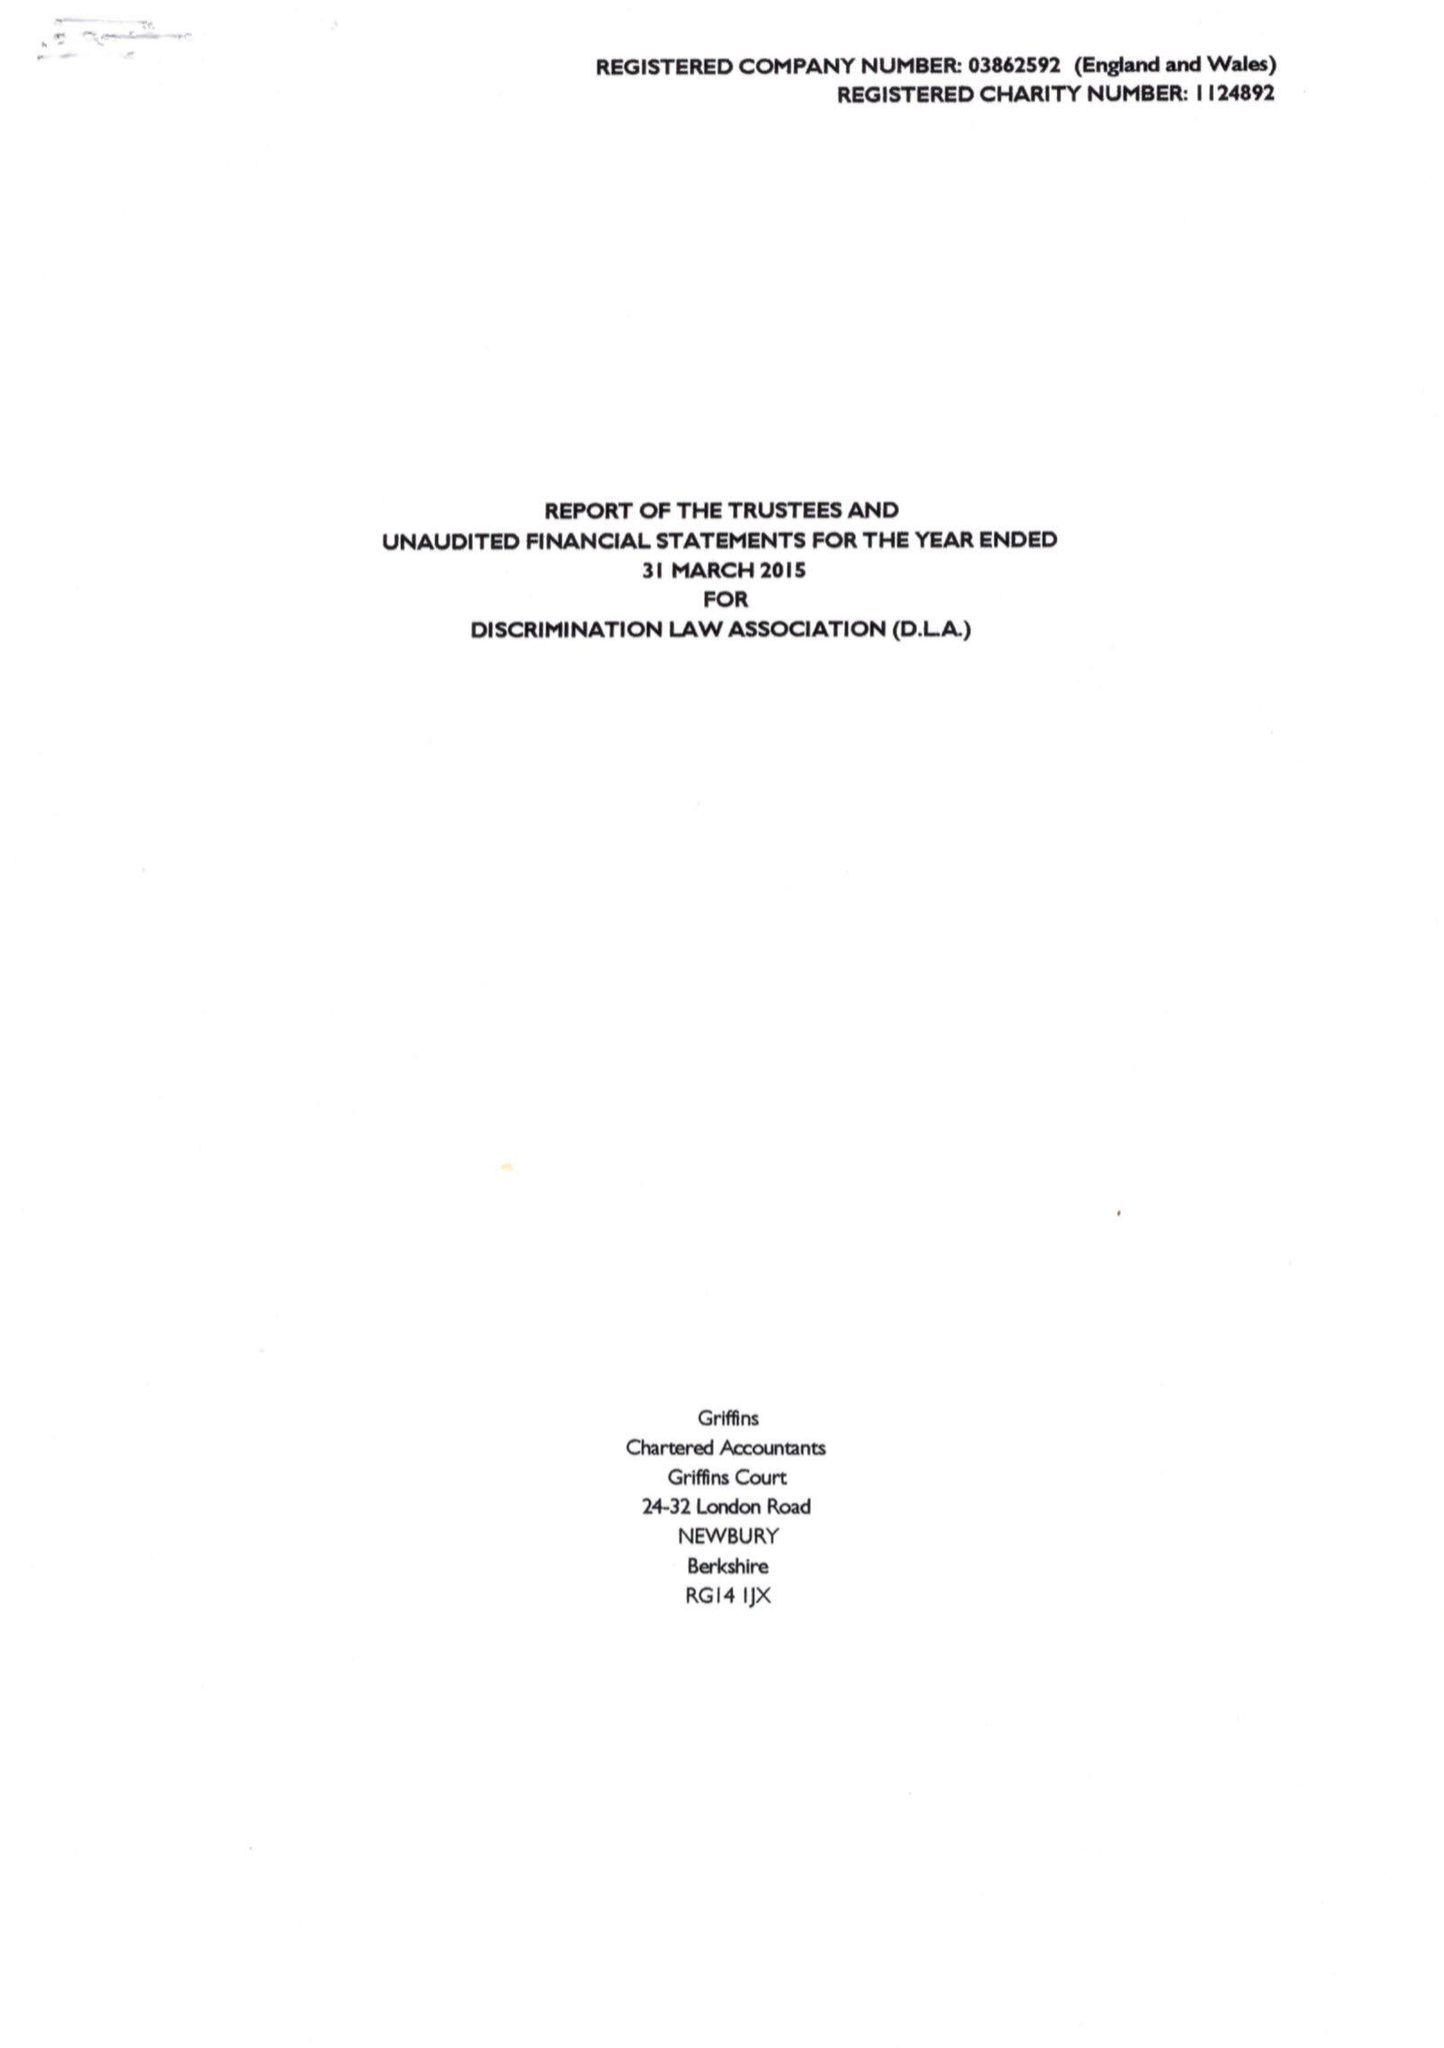What is the value for the address__postcode?
Answer the question using a single word or phrase. N6 5HN 